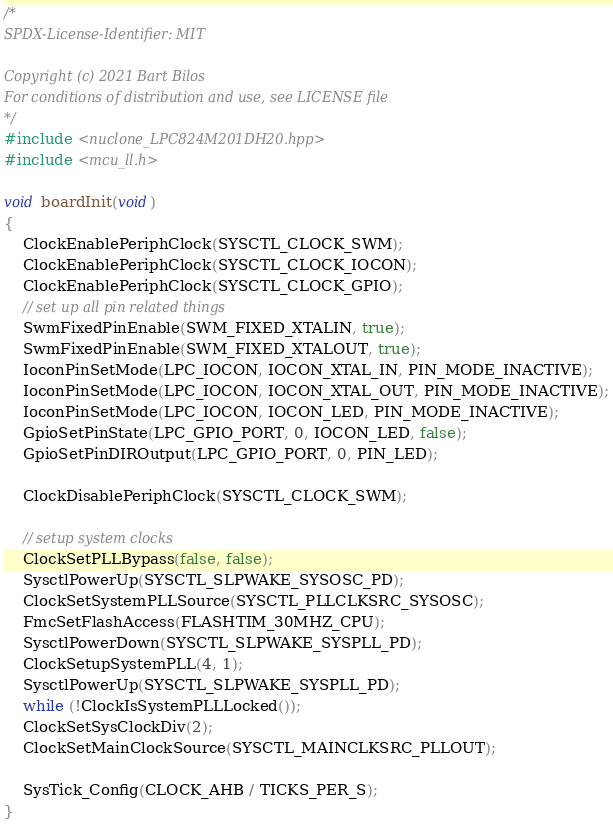<code> <loc_0><loc_0><loc_500><loc_500><_C++_>/*
SPDX-License-Identifier: MIT

Copyright (c) 2021 Bart Bilos
For conditions of distribution and use, see LICENSE file
*/
#include <nuclone_LPC824M201DH20.hpp>
#include <mcu_ll.h>

void boardInit(void)
{
    ClockEnablePeriphClock(SYSCTL_CLOCK_SWM);
    ClockEnablePeriphClock(SYSCTL_CLOCK_IOCON);
    ClockEnablePeriphClock(SYSCTL_CLOCK_GPIO);
    // set up all pin related things
    SwmFixedPinEnable(SWM_FIXED_XTALIN, true);
    SwmFixedPinEnable(SWM_FIXED_XTALOUT, true);
    IoconPinSetMode(LPC_IOCON, IOCON_XTAL_IN, PIN_MODE_INACTIVE);
    IoconPinSetMode(LPC_IOCON, IOCON_XTAL_OUT, PIN_MODE_INACTIVE);
    IoconPinSetMode(LPC_IOCON, IOCON_LED, PIN_MODE_INACTIVE);
    GpioSetPinState(LPC_GPIO_PORT, 0, IOCON_LED, false);
    GpioSetPinDIROutput(LPC_GPIO_PORT, 0, PIN_LED);

    ClockDisablePeriphClock(SYSCTL_CLOCK_SWM);

    // setup system clocks
    ClockSetPLLBypass(false, false);
    SysctlPowerUp(SYSCTL_SLPWAKE_SYSOSC_PD);
    ClockSetSystemPLLSource(SYSCTL_PLLCLKSRC_SYSOSC);
    FmcSetFlashAccess(FLASHTIM_30MHZ_CPU);
    SysctlPowerDown(SYSCTL_SLPWAKE_SYSPLL_PD);
    ClockSetupSystemPLL(4, 1);
    SysctlPowerUp(SYSCTL_SLPWAKE_SYSPLL_PD);
    while (!ClockIsSystemPLLLocked());
    ClockSetSysClockDiv(2);
    ClockSetMainClockSource(SYSCTL_MAINCLKSRC_PLLOUT);

    SysTick_Config(CLOCK_AHB / TICKS_PER_S);
}
</code> 